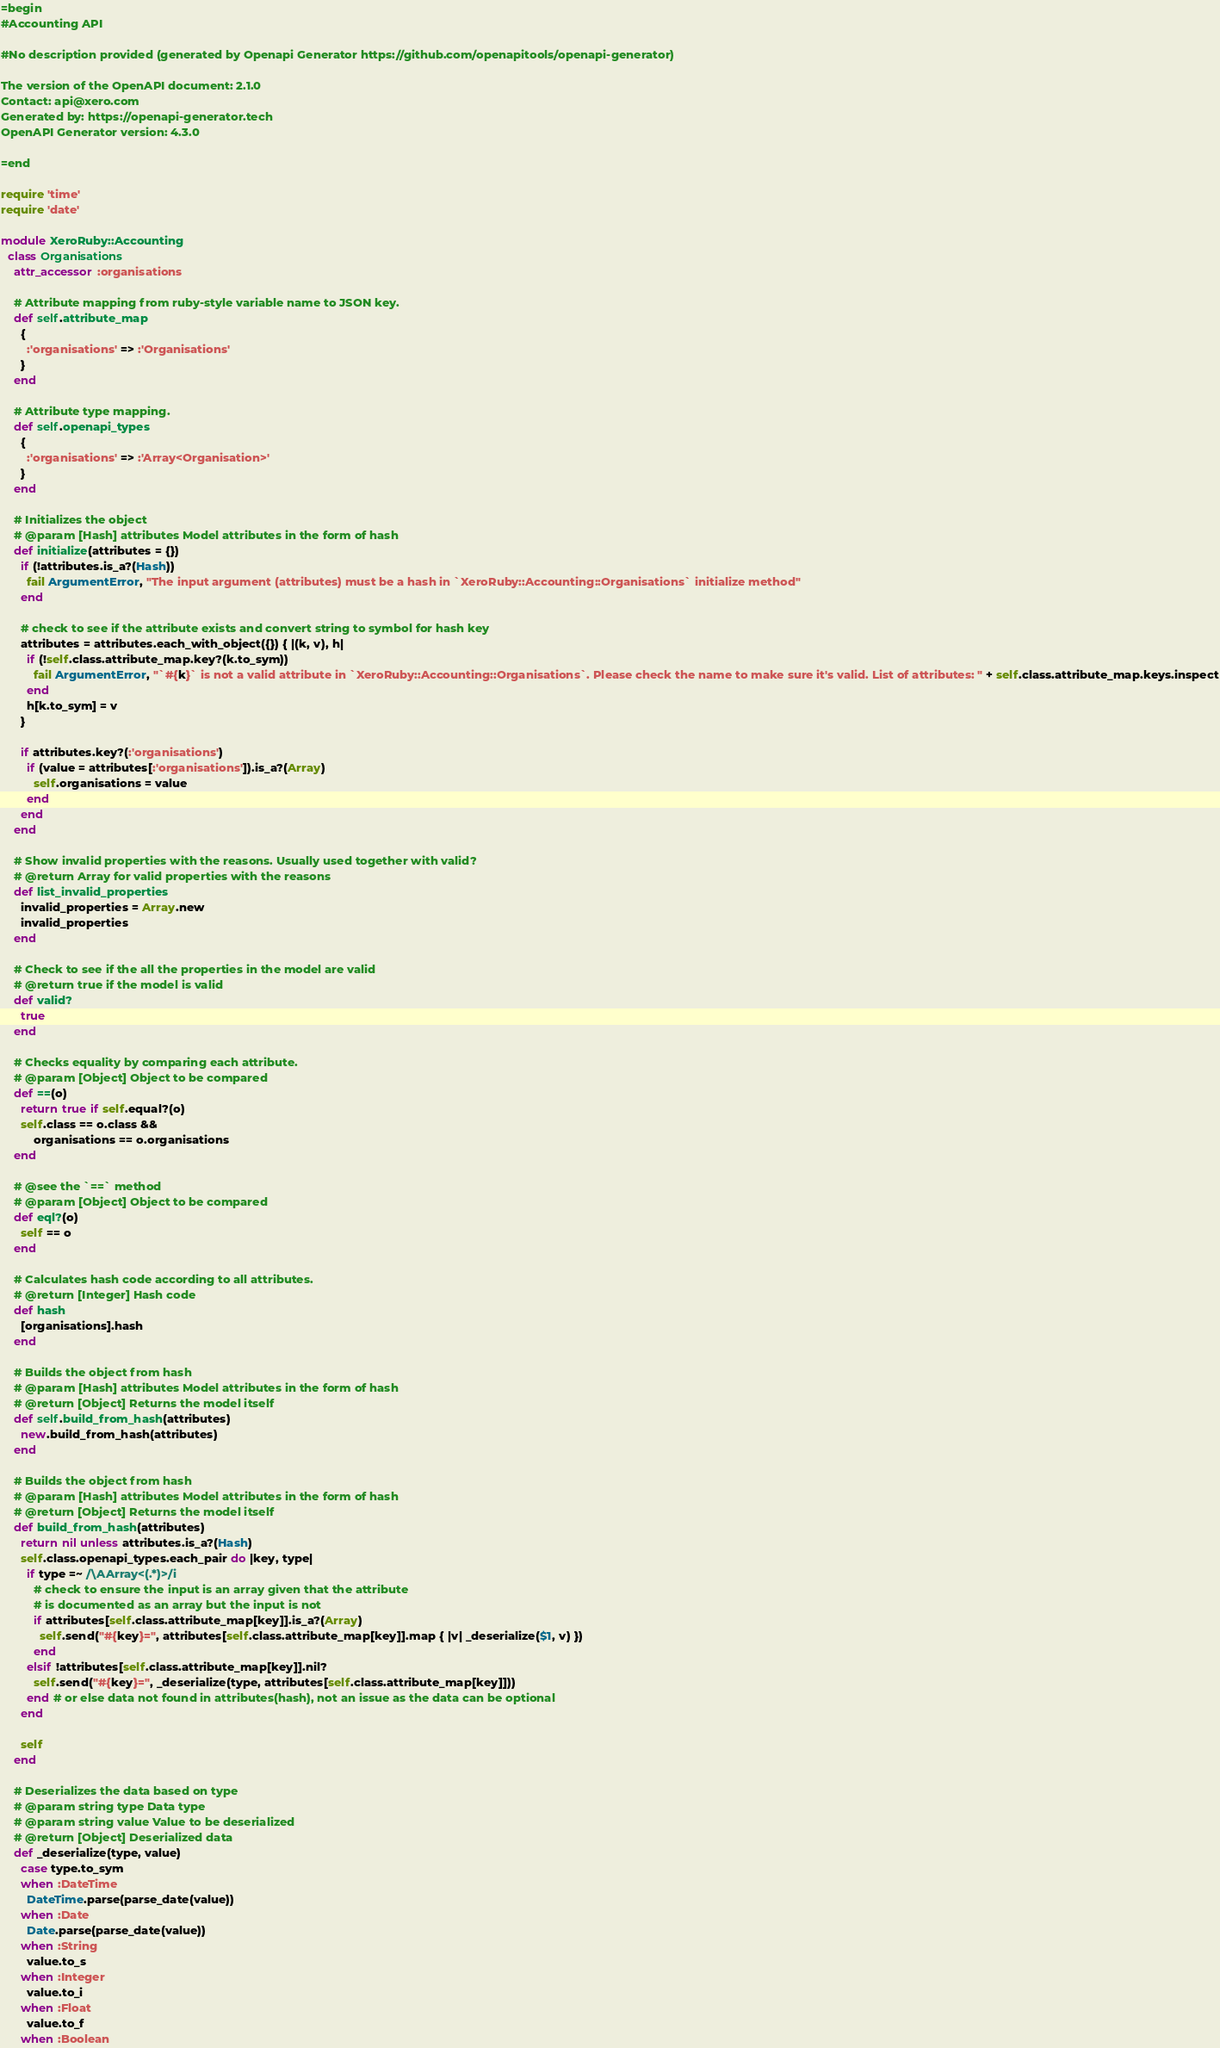<code> <loc_0><loc_0><loc_500><loc_500><_Ruby_>=begin
#Accounting API

#No description provided (generated by Openapi Generator https://github.com/openapitools/openapi-generator)

The version of the OpenAPI document: 2.1.0
Contact: api@xero.com
Generated by: https://openapi-generator.tech
OpenAPI Generator version: 4.3.0

=end

require 'time'
require 'date'

module XeroRuby::Accounting
  class Organisations
    attr_accessor :organisations

    # Attribute mapping from ruby-style variable name to JSON key.
    def self.attribute_map
      {
        :'organisations' => :'Organisations'
      }
    end

    # Attribute type mapping.
    def self.openapi_types
      {
        :'organisations' => :'Array<Organisation>'
      }
    end

    # Initializes the object
    # @param [Hash] attributes Model attributes in the form of hash
    def initialize(attributes = {})
      if (!attributes.is_a?(Hash))
        fail ArgumentError, "The input argument (attributes) must be a hash in `XeroRuby::Accounting::Organisations` initialize method"
      end

      # check to see if the attribute exists and convert string to symbol for hash key
      attributes = attributes.each_with_object({}) { |(k, v), h|
        if (!self.class.attribute_map.key?(k.to_sym))
          fail ArgumentError, "`#{k}` is not a valid attribute in `XeroRuby::Accounting::Organisations`. Please check the name to make sure it's valid. List of attributes: " + self.class.attribute_map.keys.inspect
        end
        h[k.to_sym] = v
      }

      if attributes.key?(:'organisations')
        if (value = attributes[:'organisations']).is_a?(Array)
          self.organisations = value
        end
      end
    end

    # Show invalid properties with the reasons. Usually used together with valid?
    # @return Array for valid properties with the reasons
    def list_invalid_properties
      invalid_properties = Array.new
      invalid_properties
    end

    # Check to see if the all the properties in the model are valid
    # @return true if the model is valid
    def valid?
      true
    end

    # Checks equality by comparing each attribute.
    # @param [Object] Object to be compared
    def ==(o)
      return true if self.equal?(o)
      self.class == o.class &&
          organisations == o.organisations
    end

    # @see the `==` method
    # @param [Object] Object to be compared
    def eql?(o)
      self == o
    end

    # Calculates hash code according to all attributes.
    # @return [Integer] Hash code
    def hash
      [organisations].hash
    end

    # Builds the object from hash
    # @param [Hash] attributes Model attributes in the form of hash
    # @return [Object] Returns the model itself
    def self.build_from_hash(attributes)
      new.build_from_hash(attributes)
    end

    # Builds the object from hash
    # @param [Hash] attributes Model attributes in the form of hash
    # @return [Object] Returns the model itself
    def build_from_hash(attributes)
      return nil unless attributes.is_a?(Hash)
      self.class.openapi_types.each_pair do |key, type|
        if type =~ /\AArray<(.*)>/i
          # check to ensure the input is an array given that the attribute
          # is documented as an array but the input is not
          if attributes[self.class.attribute_map[key]].is_a?(Array)
            self.send("#{key}=", attributes[self.class.attribute_map[key]].map { |v| _deserialize($1, v) })
          end
        elsif !attributes[self.class.attribute_map[key]].nil?
          self.send("#{key}=", _deserialize(type, attributes[self.class.attribute_map[key]]))
        end # or else data not found in attributes(hash), not an issue as the data can be optional
      end

      self
    end

    # Deserializes the data based on type
    # @param string type Data type
    # @param string value Value to be deserialized
    # @return [Object] Deserialized data
    def _deserialize(type, value)
      case type.to_sym
      when :DateTime
        DateTime.parse(parse_date(value))
      when :Date
        Date.parse(parse_date(value))
      when :String
        value.to_s
      when :Integer
        value.to_i
      when :Float
        value.to_f
      when :Boolean</code> 